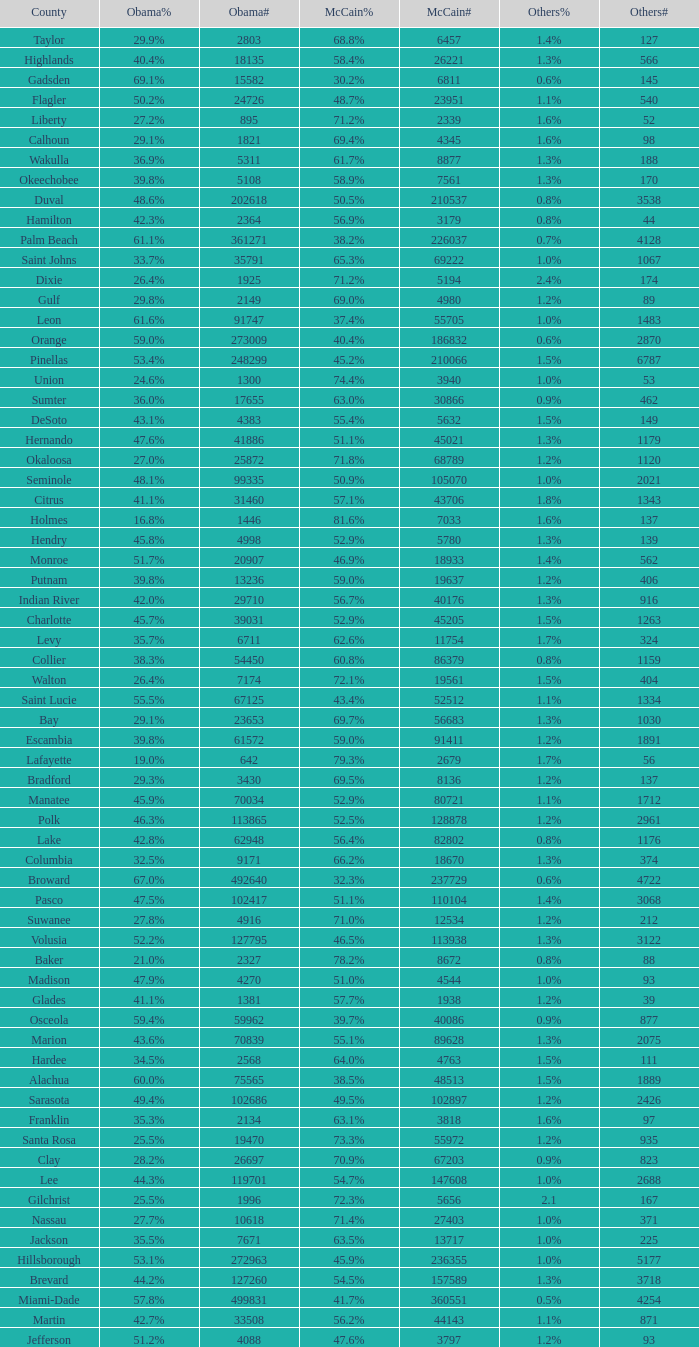What percentage was the others vote when McCain had 52.9% and less than 45205.0 voters? 1.3%. 